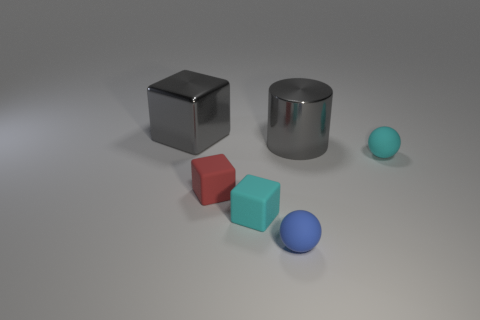There is a metallic object that is in front of the gray cube; is its size the same as the small blue thing?
Make the answer very short. No. Are there any small blocks that are in front of the big gray metallic block to the left of the cylinder?
Keep it short and to the point. Yes. What material is the big cylinder?
Your answer should be very brief. Metal. There is a red block; are there any rubber spheres to the left of it?
Give a very brief answer. No. What size is the other matte object that is the same shape as the tiny red object?
Make the answer very short. Small. Is the number of tiny red cubes behind the tiny red matte object the same as the number of small red objects that are on the right side of the tiny blue thing?
Ensure brevity in your answer.  Yes. What number of large blocks are there?
Offer a terse response. 1. Is the number of matte balls on the left side of the red rubber cube greater than the number of big gray metallic cylinders?
Offer a very short reply. No. What is the material of the big gray thing to the left of the tiny red rubber cube?
Provide a succinct answer. Metal. What is the color of the other rubber thing that is the same shape as the blue thing?
Your response must be concise. Cyan. 